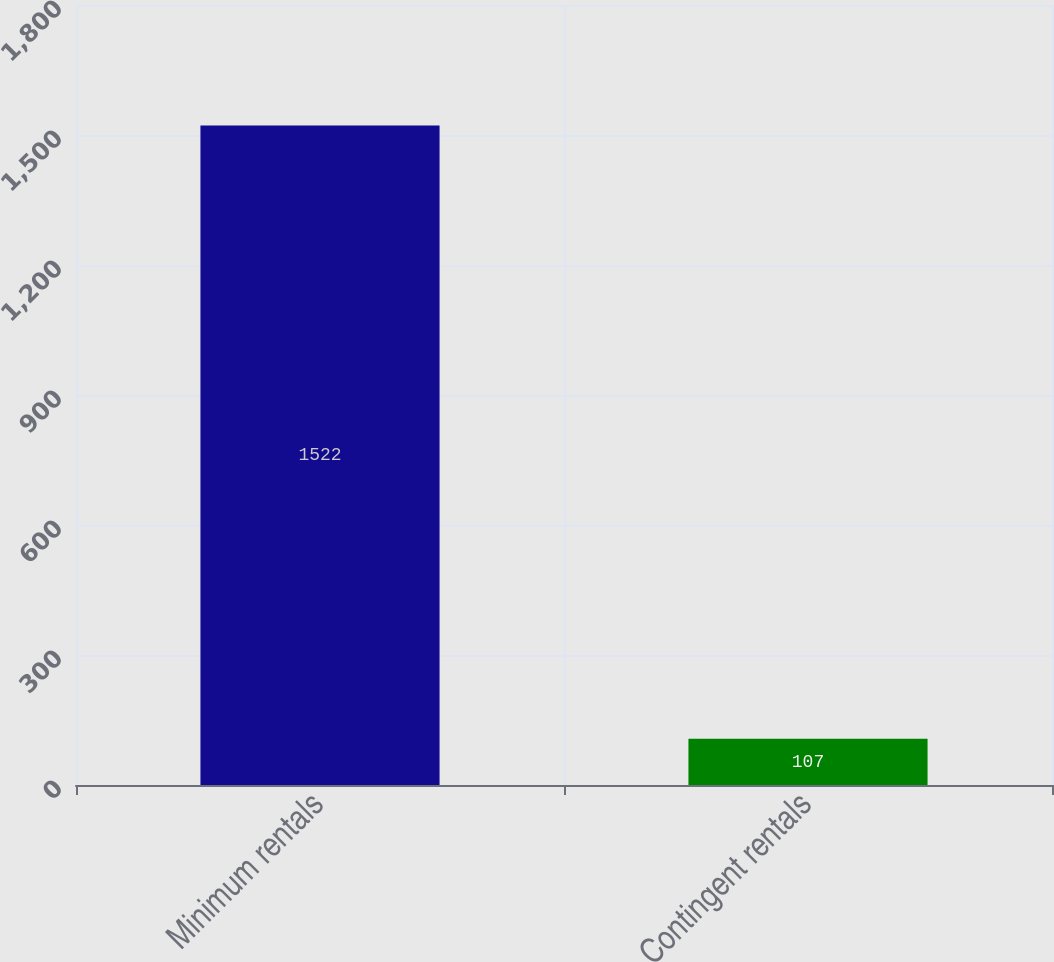<chart> <loc_0><loc_0><loc_500><loc_500><bar_chart><fcel>Minimum rentals<fcel>Contingent rentals<nl><fcel>1522<fcel>107<nl></chart> 